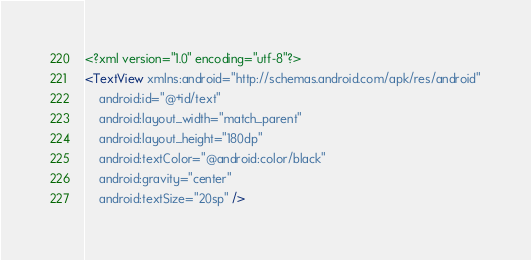Convert code to text. <code><loc_0><loc_0><loc_500><loc_500><_XML_><?xml version="1.0" encoding="utf-8"?>
<TextView xmlns:android="http://schemas.android.com/apk/res/android"
    android:id="@+id/text"
    android:layout_width="match_parent"
    android:layout_height="180dp"
    android:textColor="@android:color/black"
    android:gravity="center"
    android:textSize="20sp" /></code> 